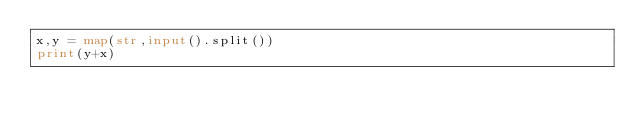Convert code to text. <code><loc_0><loc_0><loc_500><loc_500><_Python_>x,y = map(str,input().split())
print(y+x)</code> 